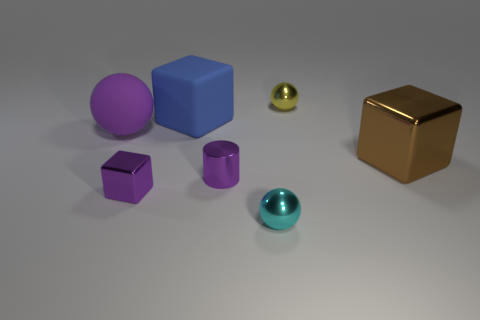What number of objects are big matte things to the left of the big blue matte cube or tiny yellow matte cubes?
Give a very brief answer. 1. There is a metal cube that is behind the block that is in front of the purple metallic object that is right of the large rubber block; what color is it?
Provide a succinct answer. Brown. What is the color of the sphere that is made of the same material as the large blue block?
Give a very brief answer. Purple. What number of small purple blocks have the same material as the purple ball?
Keep it short and to the point. 0. There is a shiny cube in front of the brown metal block; is its size the same as the large blue matte object?
Make the answer very short. No. The cylinder that is the same size as the cyan metallic sphere is what color?
Provide a succinct answer. Purple. There is a big metallic thing; how many small metallic cubes are behind it?
Keep it short and to the point. 0. Are any gray matte blocks visible?
Make the answer very short. No. How big is the shiny cube that is left of the small metal ball behind the tiny purple thing that is behind the tiny metal block?
Ensure brevity in your answer.  Small. How many other things are the same size as the blue thing?
Give a very brief answer. 2. 